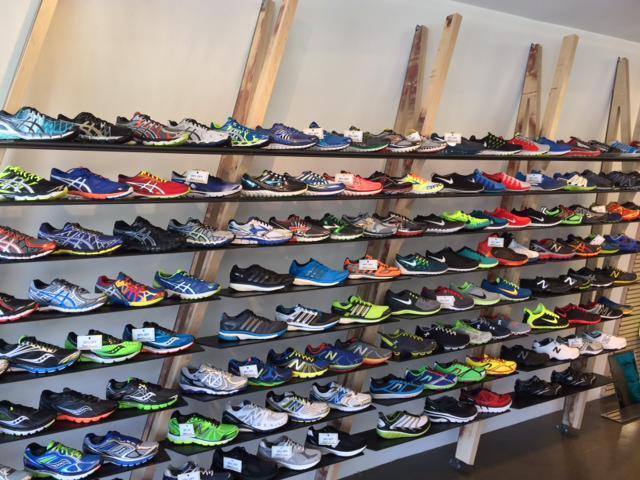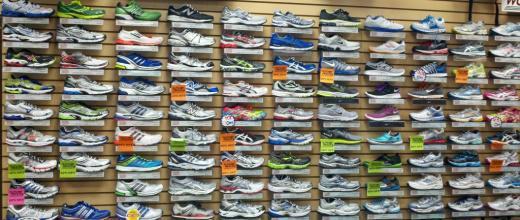The first image is the image on the left, the second image is the image on the right. Given the left and right images, does the statement "The shoes are displayed horizontally on the wall in the image on the right." hold true? Answer yes or no. Yes. 